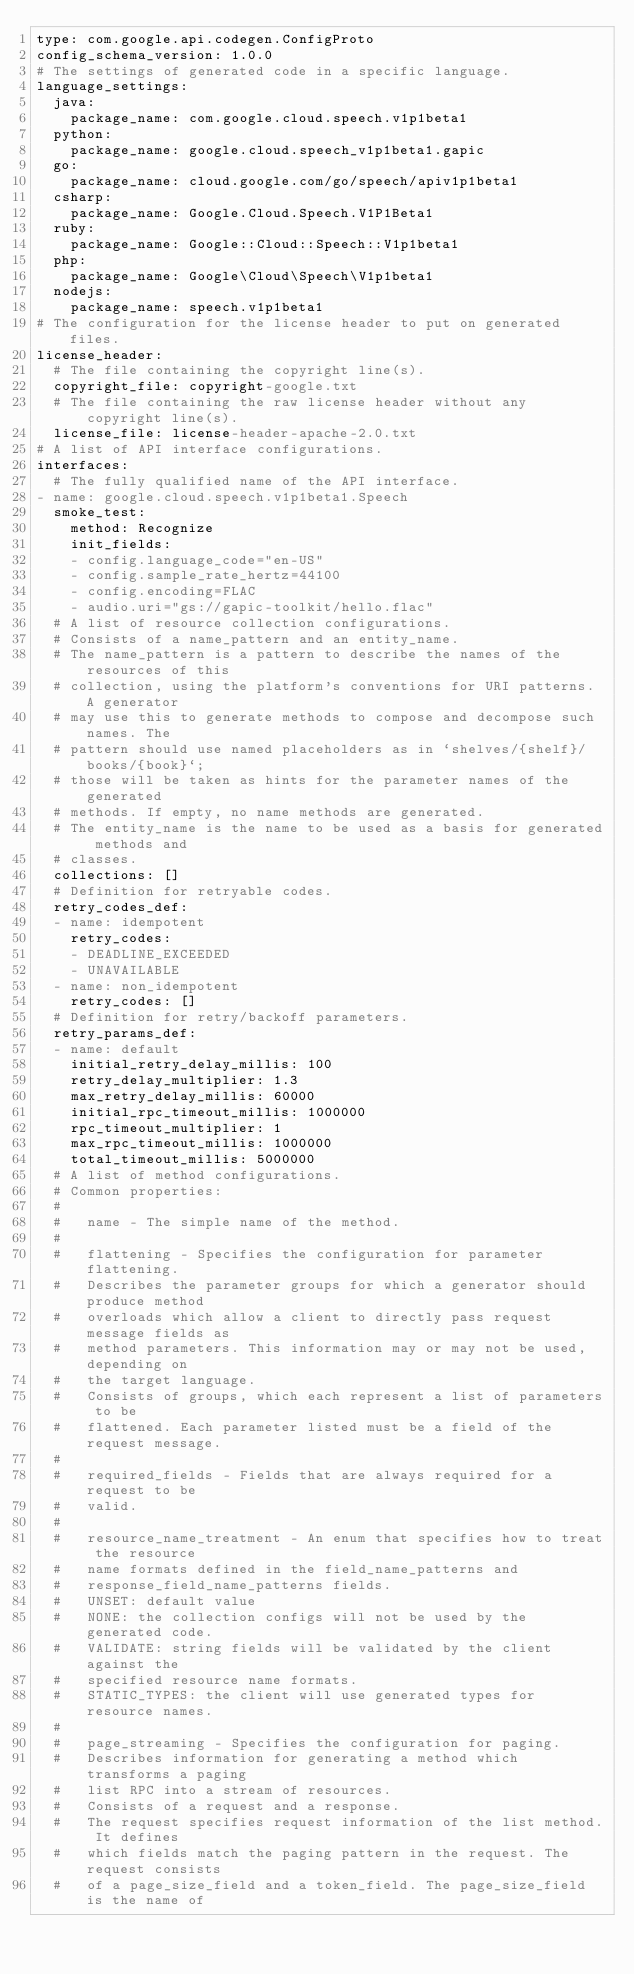<code> <loc_0><loc_0><loc_500><loc_500><_YAML_>type: com.google.api.codegen.ConfigProto
config_schema_version: 1.0.0
# The settings of generated code in a specific language.
language_settings:
  java:
    package_name: com.google.cloud.speech.v1p1beta1
  python:
    package_name: google.cloud.speech_v1p1beta1.gapic
  go:
    package_name: cloud.google.com/go/speech/apiv1p1beta1
  csharp:
    package_name: Google.Cloud.Speech.V1P1Beta1
  ruby:
    package_name: Google::Cloud::Speech::V1p1beta1
  php:
    package_name: Google\Cloud\Speech\V1p1beta1
  nodejs:
    package_name: speech.v1p1beta1
# The configuration for the license header to put on generated files.
license_header:
  # The file containing the copyright line(s).
  copyright_file: copyright-google.txt
  # The file containing the raw license header without any copyright line(s).
  license_file: license-header-apache-2.0.txt
# A list of API interface configurations.
interfaces:
  # The fully qualified name of the API interface.
- name: google.cloud.speech.v1p1beta1.Speech
  smoke_test:
    method: Recognize
    init_fields:
    - config.language_code="en-US"
    - config.sample_rate_hertz=44100
    - config.encoding=FLAC
    - audio.uri="gs://gapic-toolkit/hello.flac"
  # A list of resource collection configurations.
  # Consists of a name_pattern and an entity_name.
  # The name_pattern is a pattern to describe the names of the resources of this
  # collection, using the platform's conventions for URI patterns. A generator
  # may use this to generate methods to compose and decompose such names. The
  # pattern should use named placeholders as in `shelves/{shelf}/books/{book}`;
  # those will be taken as hints for the parameter names of the generated
  # methods. If empty, no name methods are generated.
  # The entity_name is the name to be used as a basis for generated methods and
  # classes.
  collections: []
  # Definition for retryable codes.
  retry_codes_def:
  - name: idempotent
    retry_codes:
    - DEADLINE_EXCEEDED
    - UNAVAILABLE
  - name: non_idempotent
    retry_codes: []
  # Definition for retry/backoff parameters.
  retry_params_def:
  - name: default
    initial_retry_delay_millis: 100
    retry_delay_multiplier: 1.3
    max_retry_delay_millis: 60000
    initial_rpc_timeout_millis: 1000000
    rpc_timeout_multiplier: 1
    max_rpc_timeout_millis: 1000000
    total_timeout_millis: 5000000
  # A list of method configurations.
  # Common properties:
  #
  #   name - The simple name of the method.
  #
  #   flattening - Specifies the configuration for parameter flattening.
  #   Describes the parameter groups for which a generator should produce method
  #   overloads which allow a client to directly pass request message fields as
  #   method parameters. This information may or may not be used, depending on
  #   the target language.
  #   Consists of groups, which each represent a list of parameters to be
  #   flattened. Each parameter listed must be a field of the request message.
  #
  #   required_fields - Fields that are always required for a request to be
  #   valid.
  #
  #   resource_name_treatment - An enum that specifies how to treat the resource
  #   name formats defined in the field_name_patterns and
  #   response_field_name_patterns fields.
  #   UNSET: default value
  #   NONE: the collection configs will not be used by the generated code.
  #   VALIDATE: string fields will be validated by the client against the
  #   specified resource name formats.
  #   STATIC_TYPES: the client will use generated types for resource names.
  #
  #   page_streaming - Specifies the configuration for paging.
  #   Describes information for generating a method which transforms a paging
  #   list RPC into a stream of resources.
  #   Consists of a request and a response.
  #   The request specifies request information of the list method. It defines
  #   which fields match the paging pattern in the request. The request consists
  #   of a page_size_field and a token_field. The page_size_field is the name of</code> 